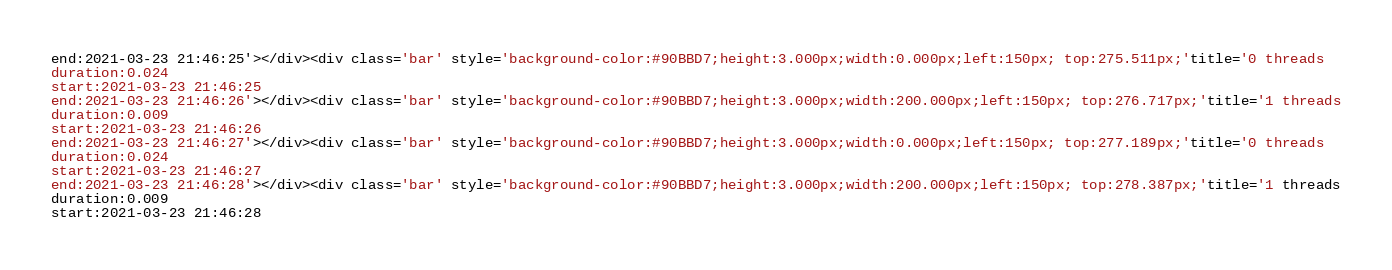Convert code to text. <code><loc_0><loc_0><loc_500><loc_500><_HTML_>end:2021-03-23 21:46:25'></div><div class='bar' style='background-color:#90BBD7;height:3.000px;width:0.000px;left:150px; top:275.511px;'title='0 threads
duration:0.024
start:2021-03-23 21:46:25
end:2021-03-23 21:46:26'></div><div class='bar' style='background-color:#90BBD7;height:3.000px;width:200.000px;left:150px; top:276.717px;'title='1 threads
duration:0.009
start:2021-03-23 21:46:26
end:2021-03-23 21:46:27'></div><div class='bar' style='background-color:#90BBD7;height:3.000px;width:0.000px;left:150px; top:277.189px;'title='0 threads
duration:0.024
start:2021-03-23 21:46:27
end:2021-03-23 21:46:28'></div><div class='bar' style='background-color:#90BBD7;height:3.000px;width:200.000px;left:150px; top:278.387px;'title='1 threads
duration:0.009
start:2021-03-23 21:46:28</code> 